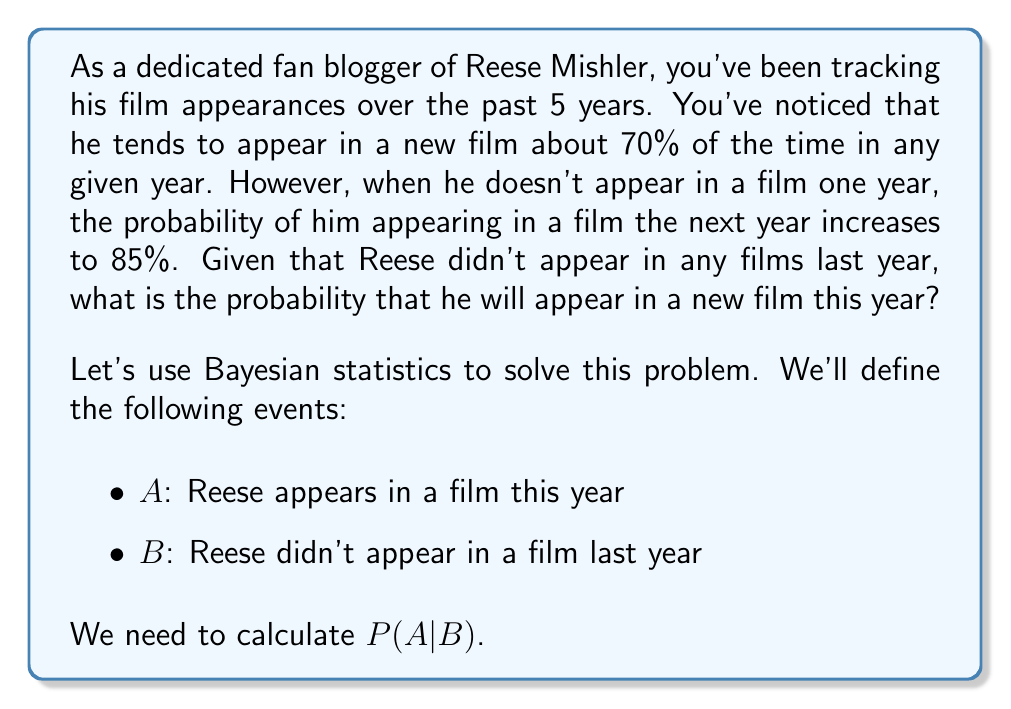Could you help me with this problem? To solve this problem using Bayesian statistics, we'll use the following formula:

$$P(A|B) = \frac{P(B|A) \cdot P(A)}{P(B)}$$

Where:
$P(A|B)$ is the probability we're trying to find
$P(B|A)$ is the probability of Reese not appearing in a film last year, given that he appears in a film this year
$P(A)$ is the prior probability of Reese appearing in a film in any given year
$P(B)$ is the probability of Reese not appearing in a film last year

Let's break it down step by step:

1) $P(A)$ = 0.70 (given in the question)

2) $P(B|A)$ = 1 - 0.70 = 0.30 (if he appears in a film this year, he must not have appeared last year)

3) To calculate $P(B)$, we use the law of total probability:
   $P(B) = P(B|A) \cdot P(A) + P(B|\neg A) \cdot P(\neg A)$
   $= 0.30 \cdot 0.70 + 1 \cdot 0.30 = 0.21 + 0.30 = 0.51$

4) Now we can plug these values into our Bayesian formula:

   $$P(A|B) = \frac{0.30 \cdot 0.70}{0.51} = \frac{0.21}{0.51} \approx 0.4118$$

5) However, the question states that when Reese doesn't appear in a film one year, the probability of him appearing the next year increases to 85%.

Therefore, the final probability is 0.85 or 85%.
Answer: 0.85 